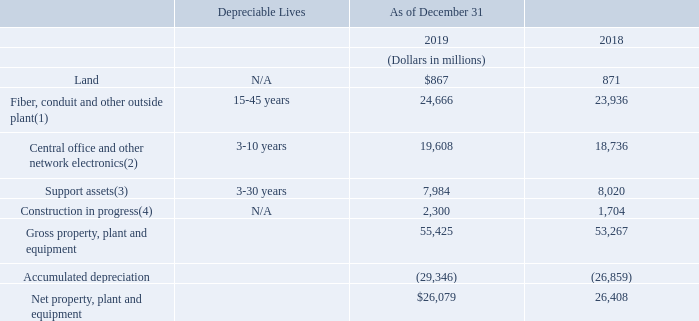(9) Property, Plant and Equipment
Net property, plant and equipment is composed of the following:
(1) Fiber, conduit and other outside plant consists of fiber and metallic cable, conduit, poles and other supporting structures.
2) Central office and other network electronics consists of circuit and packet switches, routers, transmission electronics and electronics providing service to customers.
(3) Support assets consist of buildings, cable landing stations, data centers, computers and other administrative and support equipment.
(4) Construction in progress includes inventory held for construction and property of the aforementioned categories that has not been placed in service as it is still under construction.
We recorded depreciation expense of $3.1 billion, $3.3 billion and $2.7 billion for the years ended December 31, 2019, 2018 and 2017, respectively.
What does 'Fiber, conduit and other outside plant' consist of? Fiber and metallic cable, conduit, poles and other supporting structures. What do 'Support assets' consist of? Buildings, cable landing stations, data centers, computers and other administrative and support equipment. In which years was the depreciation expense recorded? 2019, 2018, 2017. In which year was the depreciation expense recorded the largest? 3.3>3.1>2.7
Answer: 2018. What is the change in the construction in progress in 2019?
Answer scale should be: million. 2,300-1,704
Answer: 596. What is the average net property, plant and equipment?
Answer scale should be: million. (26,079+26,408)/2
Answer: 26243.5. 